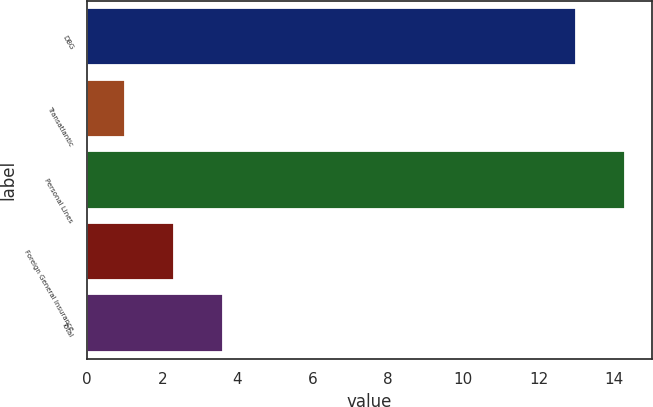<chart> <loc_0><loc_0><loc_500><loc_500><bar_chart><fcel>DBG<fcel>Transatlantic<fcel>Personal Lines<fcel>Foreign General Insurance<fcel>Total<nl><fcel>13<fcel>1<fcel>14.3<fcel>2.3<fcel>3.6<nl></chart> 